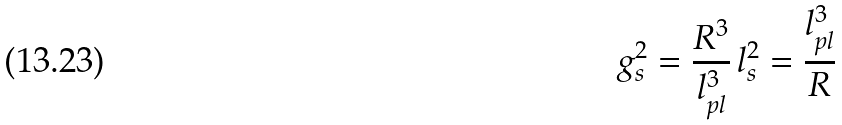<formula> <loc_0><loc_0><loc_500><loc_500>g _ { s } ^ { 2 } = \frac { R ^ { 3 } } { l _ { p l } ^ { 3 } } \, l _ { s } ^ { 2 } = \frac { l _ { p l } ^ { 3 } } { R }</formula> 